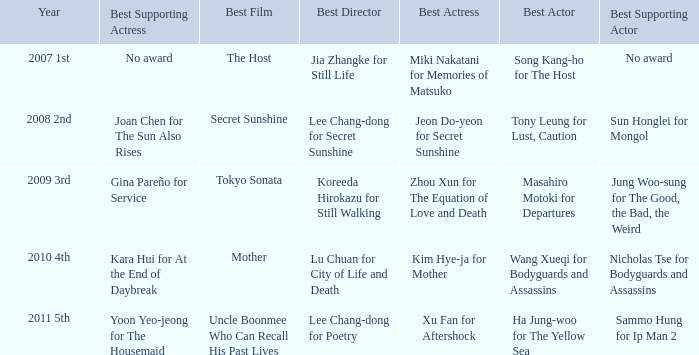Name the best director for mother Lu Chuan for City of Life and Death. 